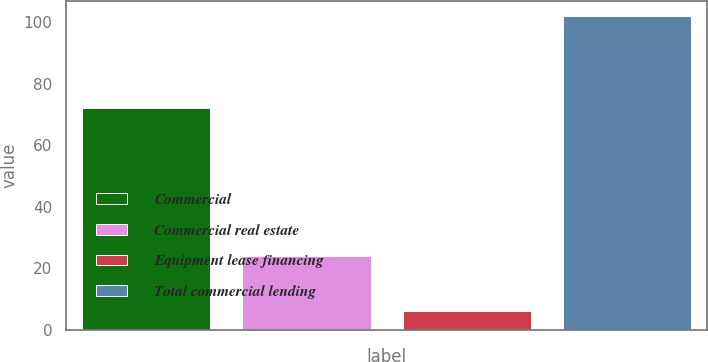Convert chart to OTSL. <chart><loc_0><loc_0><loc_500><loc_500><bar_chart><fcel>Commercial<fcel>Commercial real estate<fcel>Equipment lease financing<fcel>Total commercial lending<nl><fcel>72<fcel>24<fcel>6<fcel>102<nl></chart> 